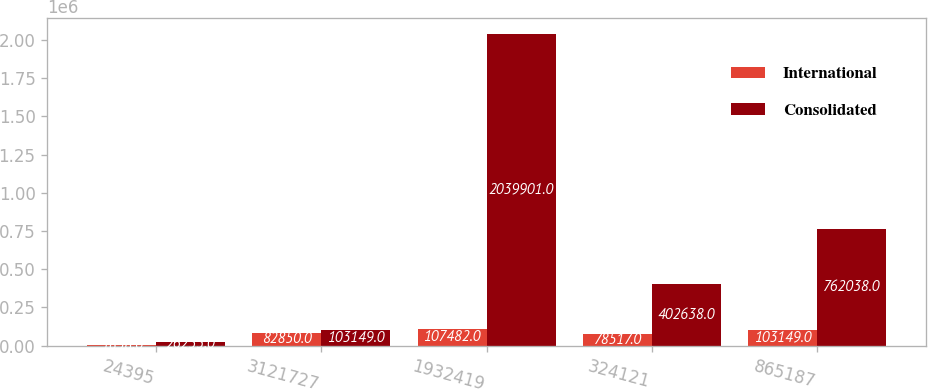Convert chart to OTSL. <chart><loc_0><loc_0><loc_500><loc_500><stacked_bar_chart><ecel><fcel>24395<fcel>3121727<fcel>1932419<fcel>324121<fcel>865187<nl><fcel>International<fcel>1858<fcel>82850<fcel>107482<fcel>78517<fcel>103149<nl><fcel>Consolidated<fcel>26253<fcel>103149<fcel>2.0399e+06<fcel>402638<fcel>762038<nl></chart> 